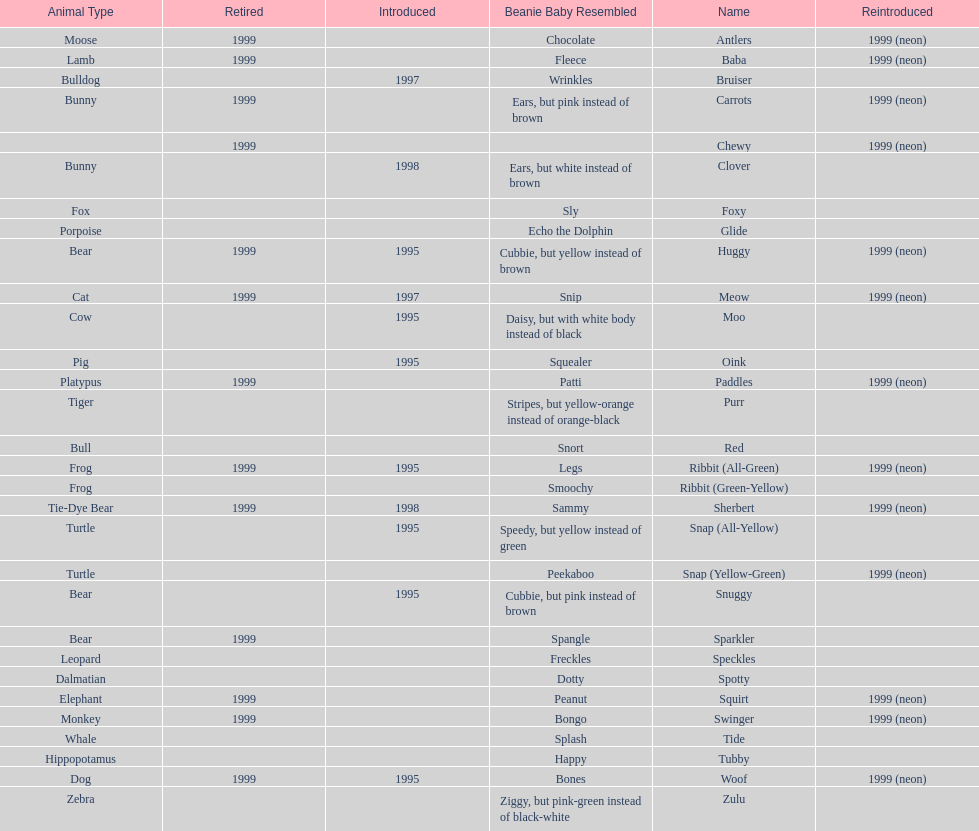Which of the listed pillow pals lack information in at least 3 categories? Chewy, Foxy, Glide, Purr, Red, Ribbit (Green-Yellow), Speckles, Spotty, Tide, Tubby, Zulu. Of those, which one lacks information in the animal type category? Chewy. 